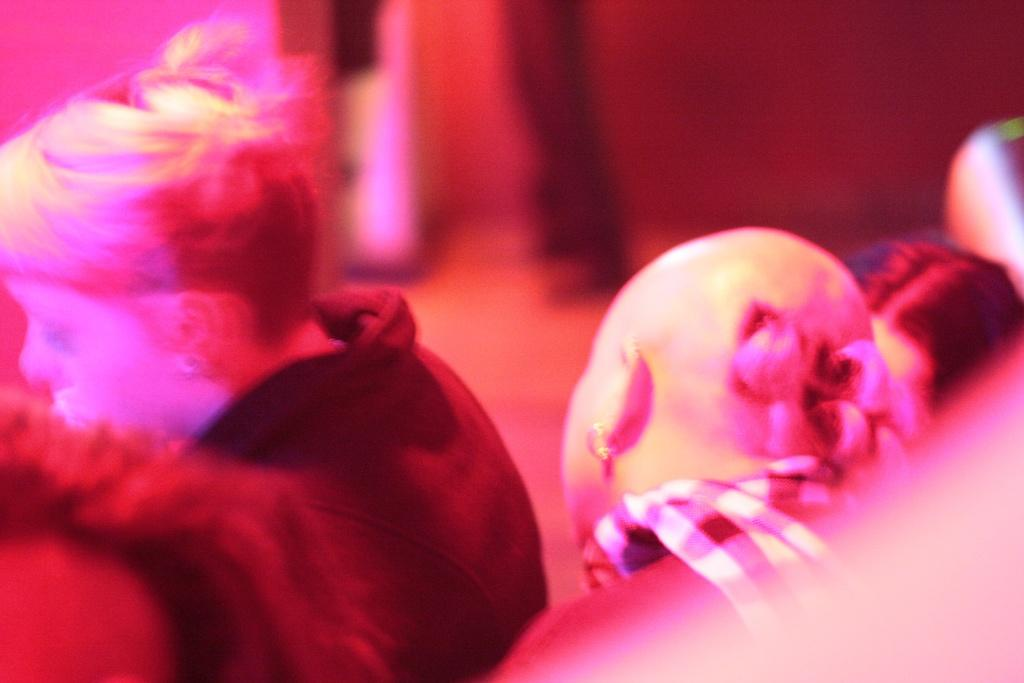What can be observed in the image that creates a visual effect? There is a light effect in the image. What is the main focus of the image? There are persons in the center of the image. How would you describe the appearance of the background in the image? The background of the image is blurry. Can you see any islands in the background of the image? There are no islands visible in the image; the background is blurry and does not show any specific location or landscape. 